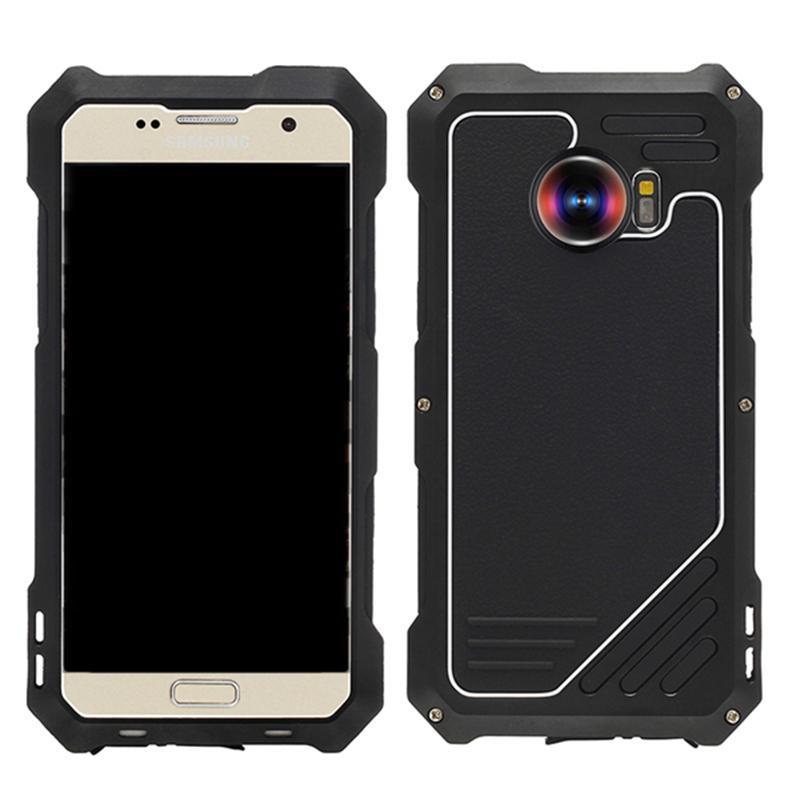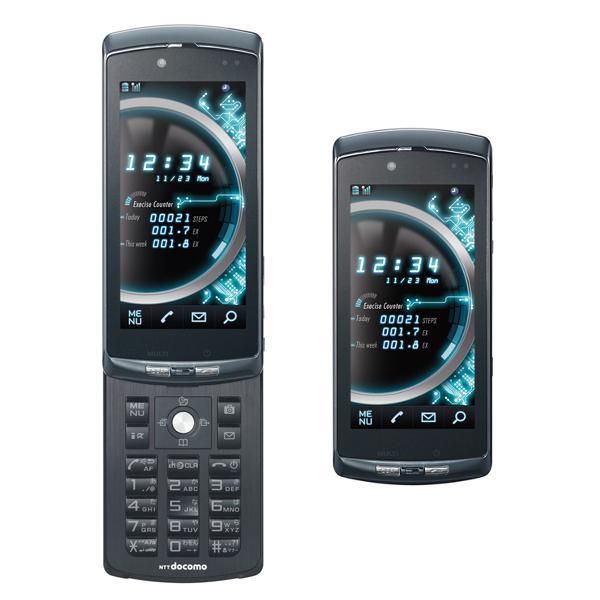The first image is the image on the left, the second image is the image on the right. Considering the images on both sides, is "One of the images shows a cell phone with app icons covering the screen and the other image shows three dark-colored cell phones." valid? Answer yes or no. No. The first image is the image on the left, the second image is the image on the right. Analyze the images presented: Is the assertion "There are exactly two black phones in the right image." valid? Answer yes or no. Yes. 